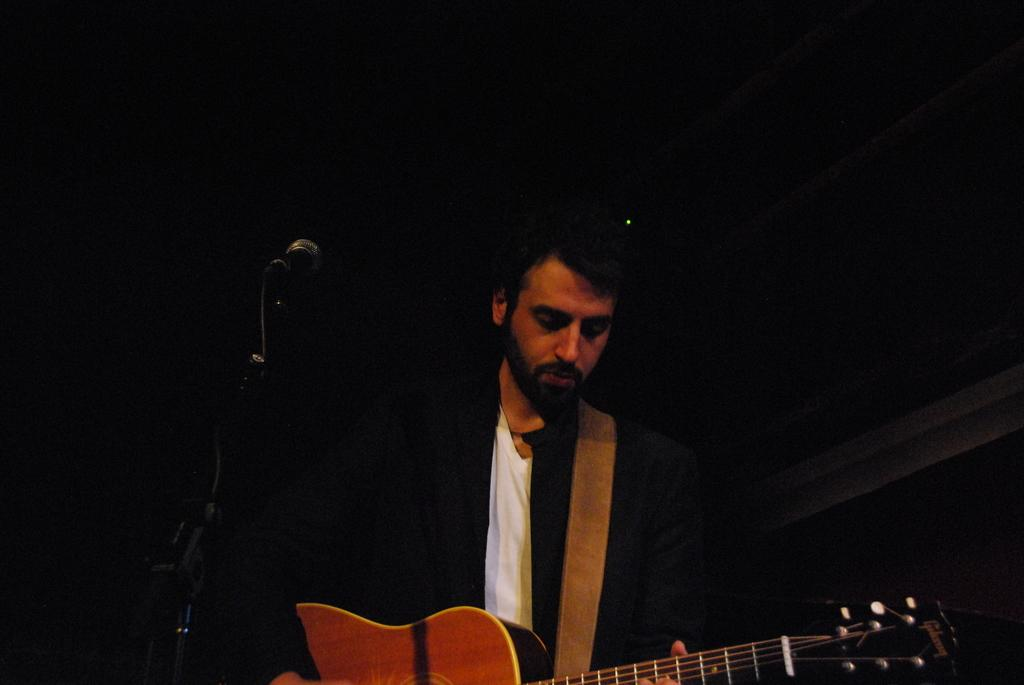Who is present in the image? There is a man in the image. What is the man doing in the image? The man is standing in the image. What object is the man holding? The man is holding a guitar in the image. What can be seen in the bottom left side of the image? There is a microphone in the bottom left side of the image. What type of bread is the man eating in the image? There is no bread present in the image; the man is holding a guitar and standing near a microphone. 